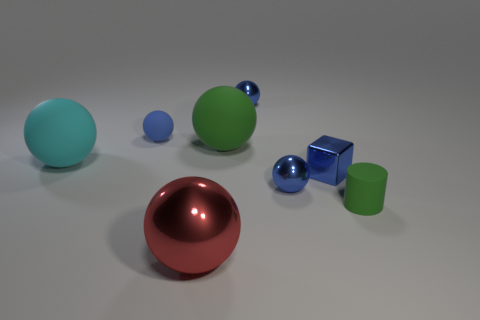How many blue balls must be subtracted to get 1 blue balls? 2 Subtract all big green spheres. How many spheres are left? 5 Add 1 cylinders. How many objects exist? 9 Subtract all blue spheres. How many spheres are left? 3 Subtract all balls. How many objects are left? 2 Subtract 3 balls. How many balls are left? 3 Subtract all red balls. Subtract all red cylinders. How many balls are left? 5 Subtract all gray cylinders. How many red spheres are left? 1 Subtract all big red spheres. Subtract all balls. How many objects are left? 1 Add 1 shiny cubes. How many shiny cubes are left? 2 